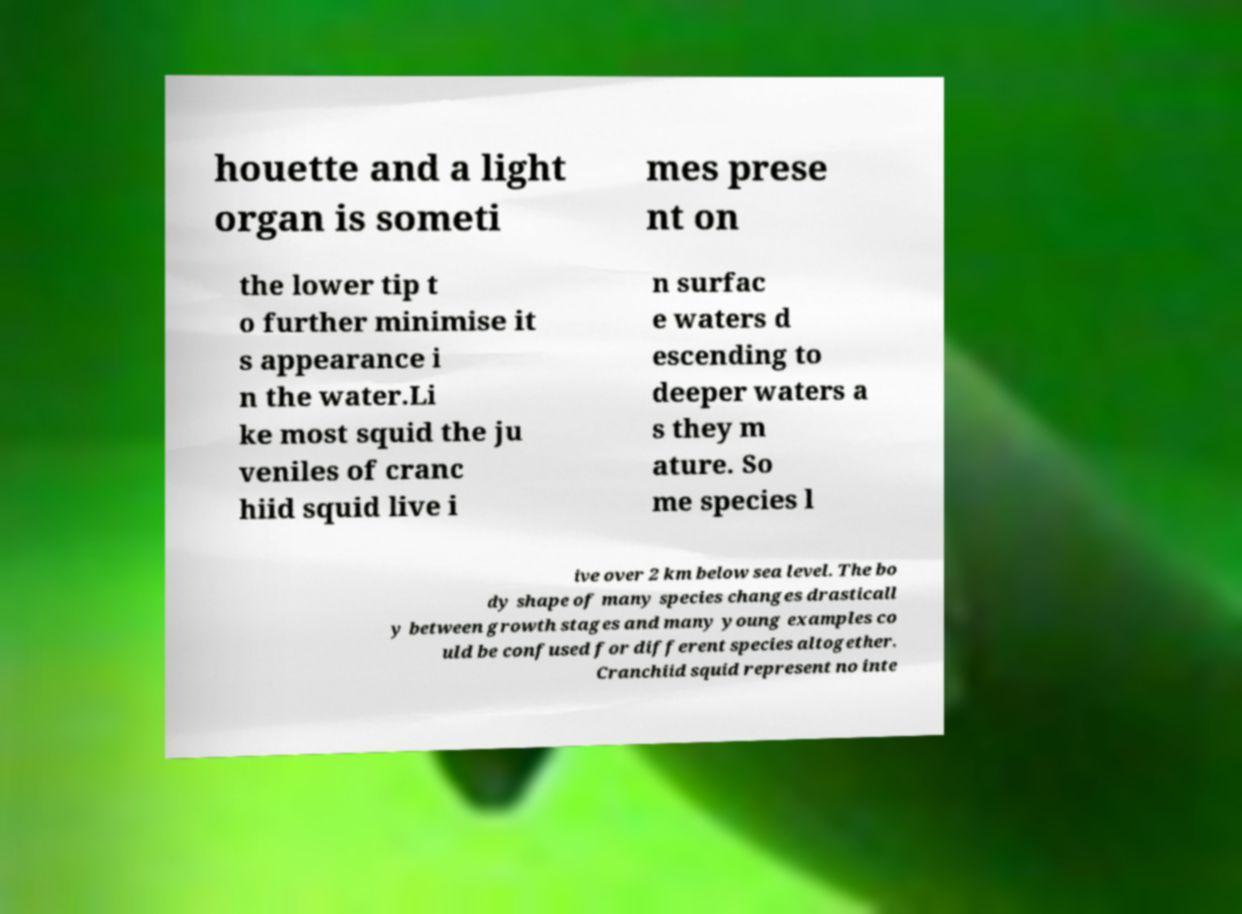Could you extract and type out the text from this image? houette and a light organ is someti mes prese nt on the lower tip t o further minimise it s appearance i n the water.Li ke most squid the ju veniles of cranc hiid squid live i n surfac e waters d escending to deeper waters a s they m ature. So me species l ive over 2 km below sea level. The bo dy shape of many species changes drasticall y between growth stages and many young examples co uld be confused for different species altogether. Cranchiid squid represent no inte 